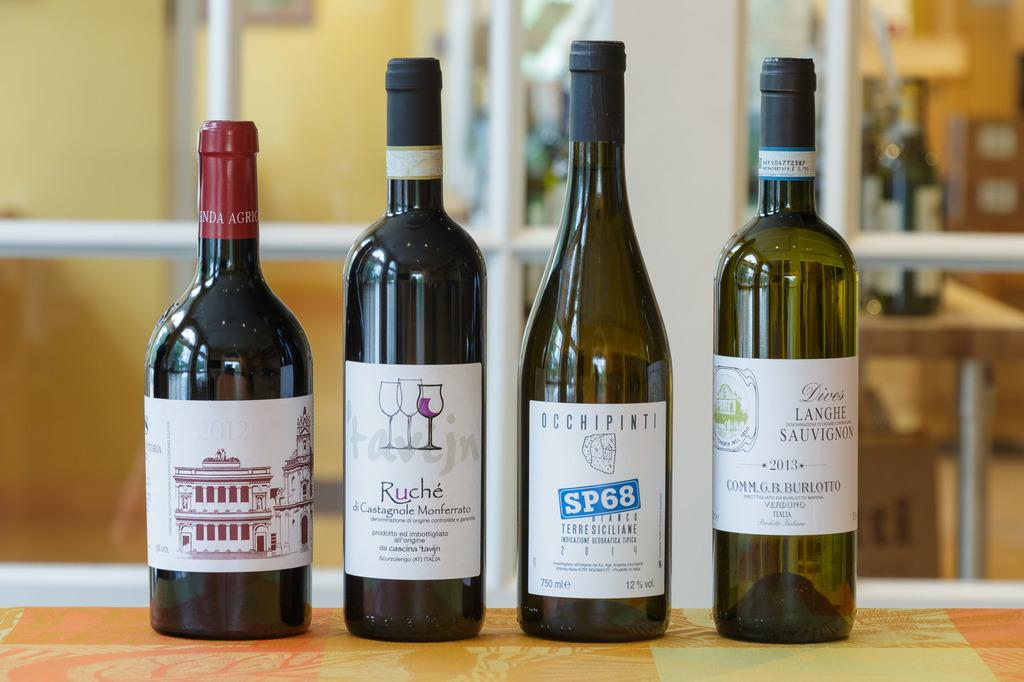What objects are on the table in the image? There are bottles on a table in the image. Can you describe the setting of the image? The image appears to be an inner view of a room. What type of jelly can be seen floating in the harbor in the image? There is no harbor or jelly present in the image; it features bottles on a table in a room. 